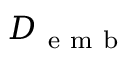<formula> <loc_0><loc_0><loc_500><loc_500>{ D _ { e m b } }</formula> 